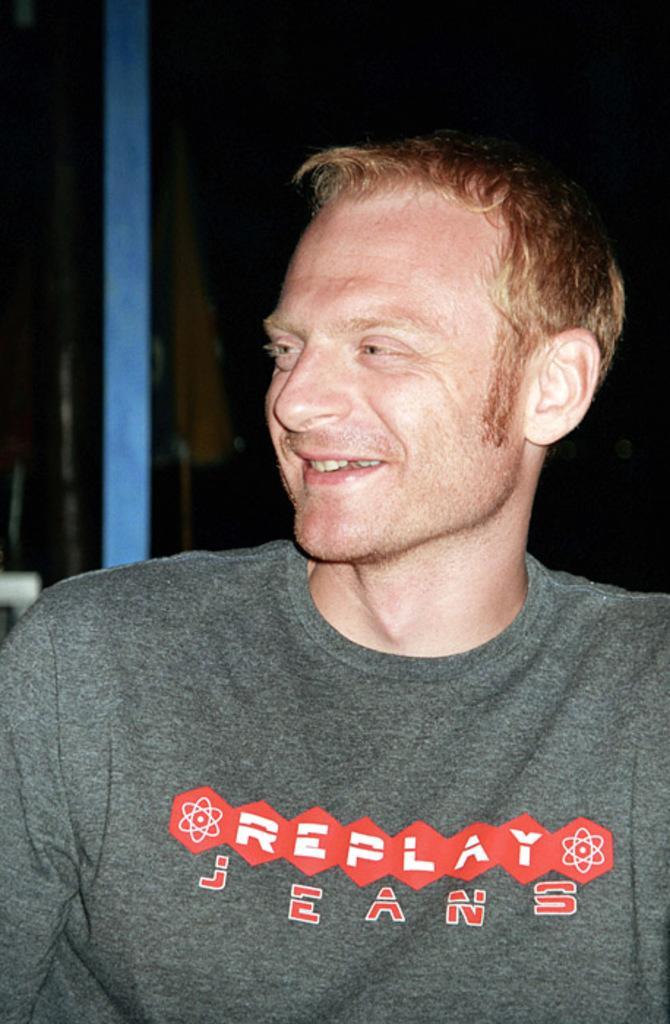Could you give a brief overview of what you see in this image? In this image we can see a person smiling and also we can see a pole and a flag, also we can see the background is dark. 